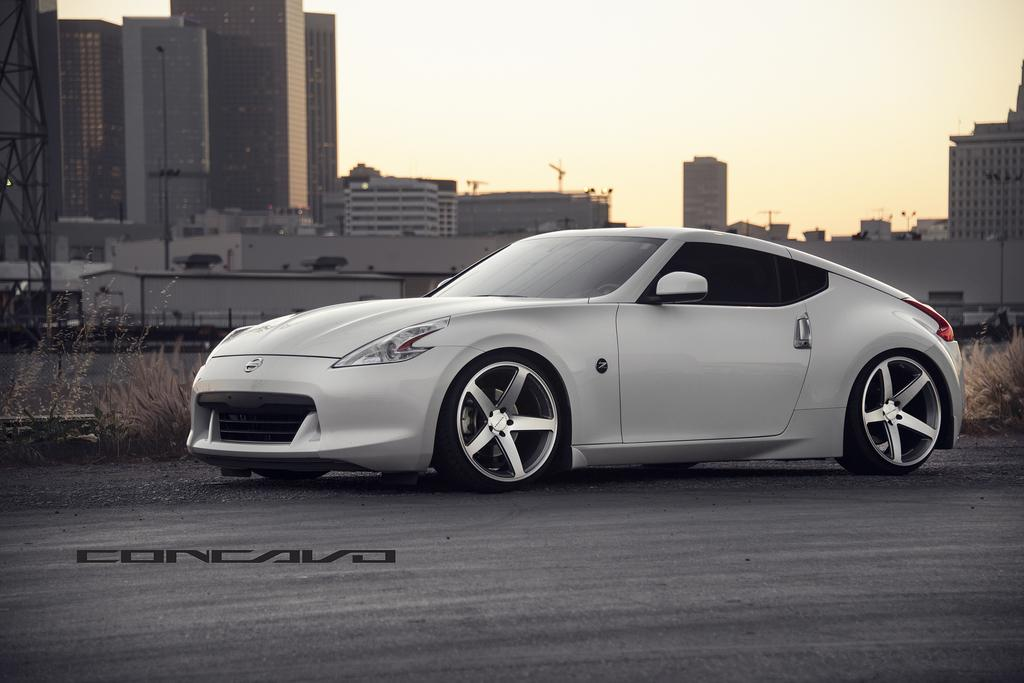What is the main subject of the image? There is a car on the road in the image. What can be seen next to the car? There are plants next to the car. What is visible in the background of the image? There are many buildings and the sky in the background of the image. How does the robin balance on the car's antenna in the image? There is no robin present in the image, so it cannot be balancing on the car's antenna. 